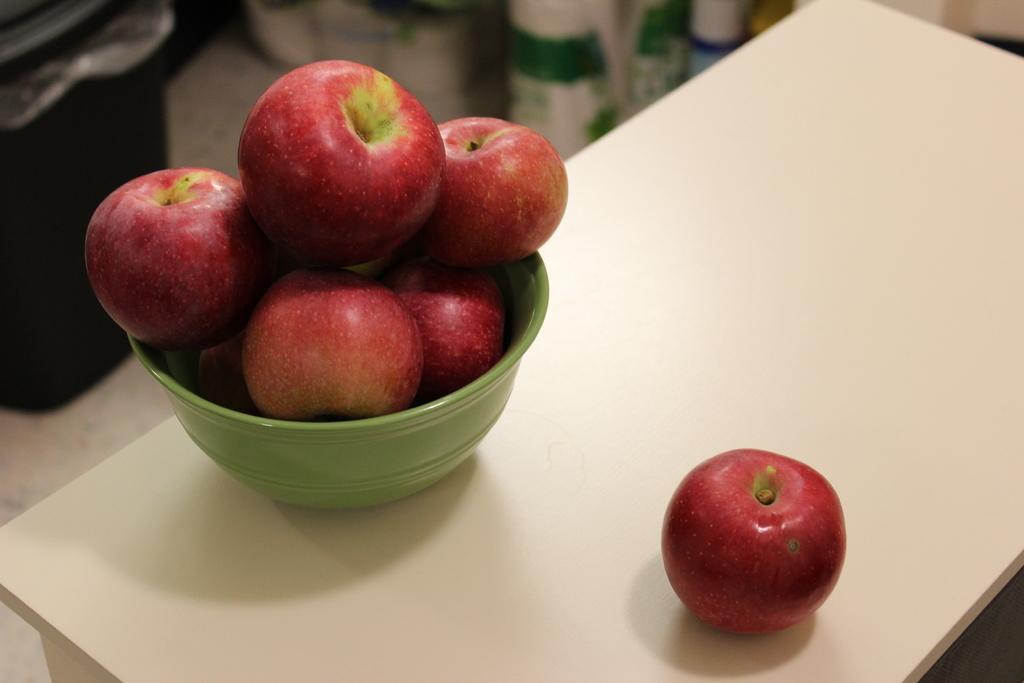Can you describe this image briefly? In the center of this picture we can see a bowl containing apples is placed on the top of the table and we can see an apple is placed on the top of the table. In the background we can see a black color container and many other objects. 